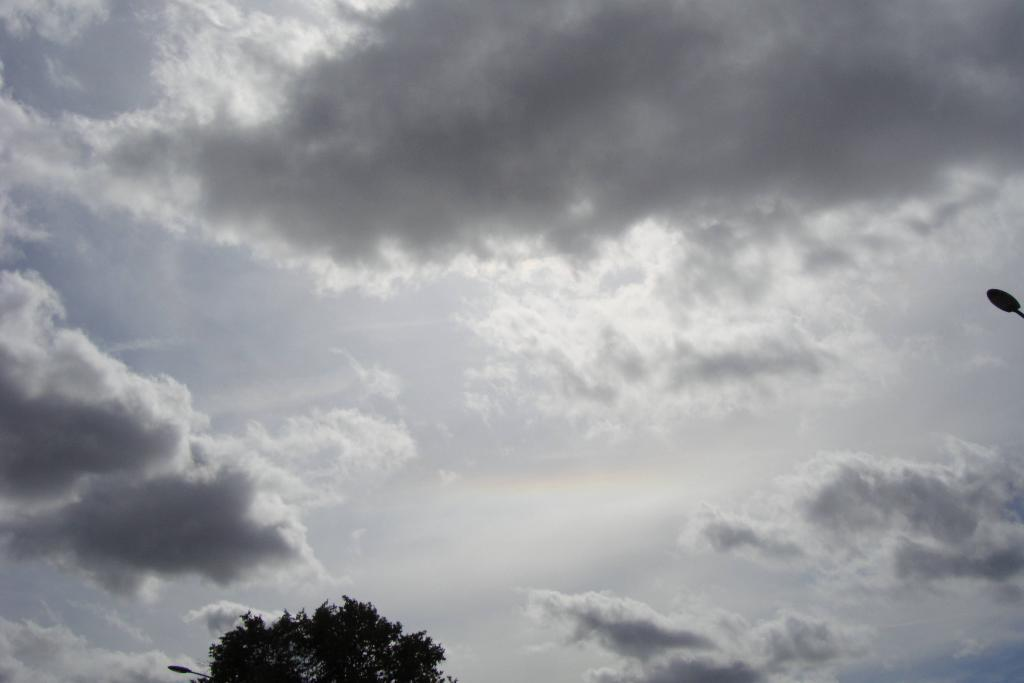What type of vegetation is present in the image? There is a tree in the image. What structures can be seen in the image besides the tree? There are light poles in the image. How would you describe the weather in the image? The sky is cloudy in the image. What type of farm animals can be seen on the voyage in the image? There is no farm or voyage present in the image; it only features a tree and light poles. 